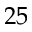Convert formula to latex. <formula><loc_0><loc_0><loc_500><loc_500>2 5</formula> 